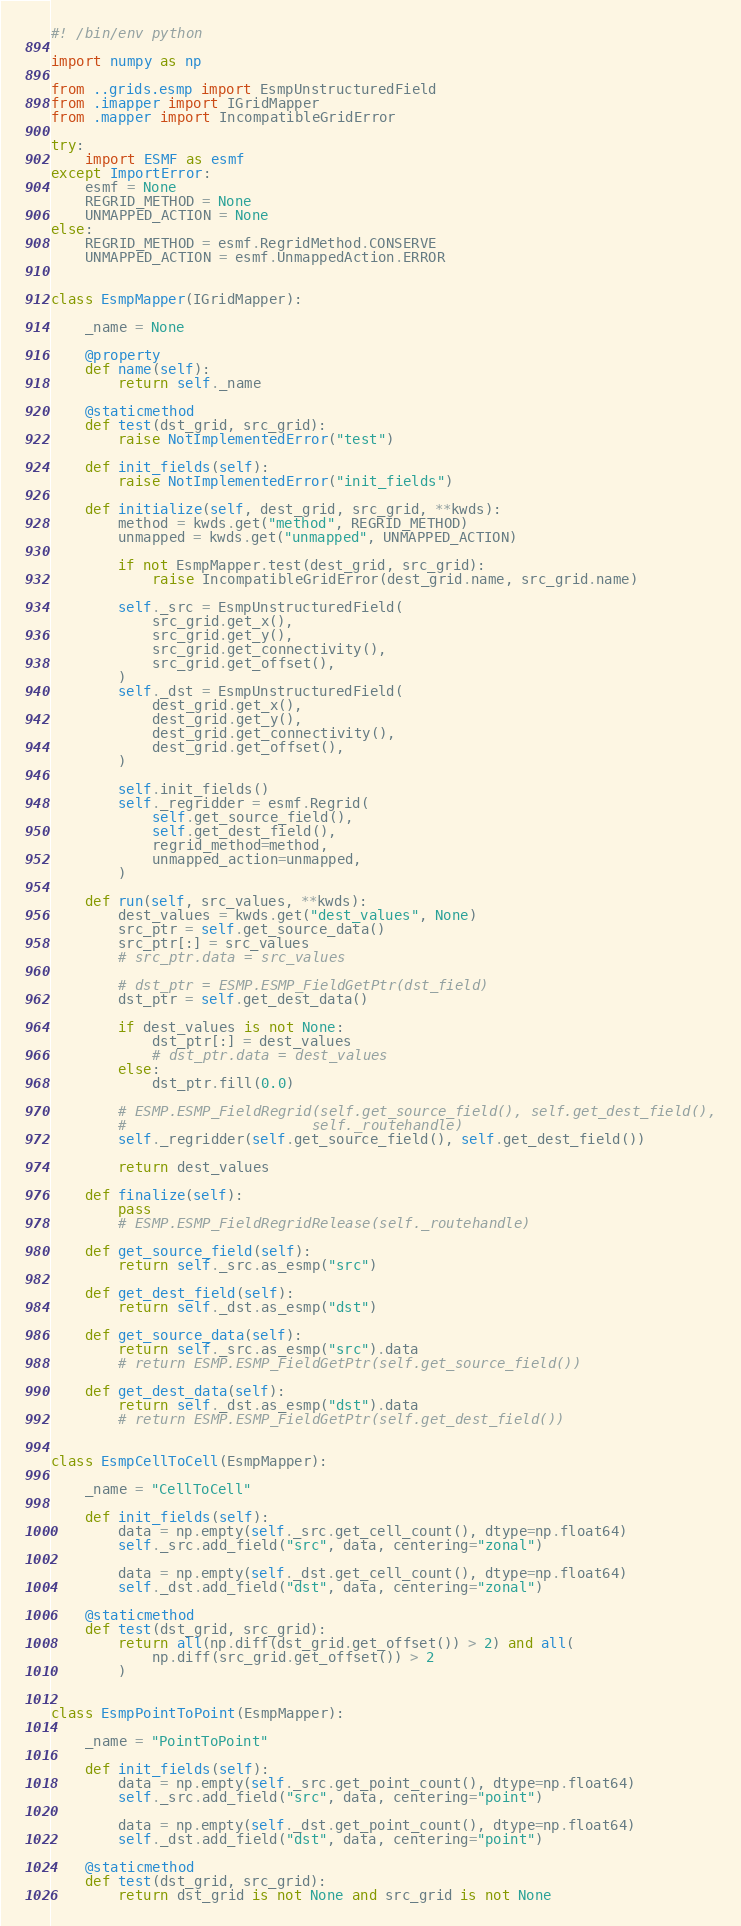Convert code to text. <code><loc_0><loc_0><loc_500><loc_500><_Python_>#! /bin/env python

import numpy as np

from ..grids.esmp import EsmpUnstructuredField
from .imapper import IGridMapper
from .mapper import IncompatibleGridError

try:
    import ESMF as esmf
except ImportError:
    esmf = None
    REGRID_METHOD = None
    UNMAPPED_ACTION = None
else:
    REGRID_METHOD = esmf.RegridMethod.CONSERVE
    UNMAPPED_ACTION = esmf.UnmappedAction.ERROR


class EsmpMapper(IGridMapper):

    _name = None

    @property
    def name(self):
        return self._name

    @staticmethod
    def test(dst_grid, src_grid):
        raise NotImplementedError("test")

    def init_fields(self):
        raise NotImplementedError("init_fields")

    def initialize(self, dest_grid, src_grid, **kwds):
        method = kwds.get("method", REGRID_METHOD)
        unmapped = kwds.get("unmapped", UNMAPPED_ACTION)

        if not EsmpMapper.test(dest_grid, src_grid):
            raise IncompatibleGridError(dest_grid.name, src_grid.name)

        self._src = EsmpUnstructuredField(
            src_grid.get_x(),
            src_grid.get_y(),
            src_grid.get_connectivity(),
            src_grid.get_offset(),
        )
        self._dst = EsmpUnstructuredField(
            dest_grid.get_x(),
            dest_grid.get_y(),
            dest_grid.get_connectivity(),
            dest_grid.get_offset(),
        )

        self.init_fields()
        self._regridder = esmf.Regrid(
            self.get_source_field(),
            self.get_dest_field(),
            regrid_method=method,
            unmapped_action=unmapped,
        )

    def run(self, src_values, **kwds):
        dest_values = kwds.get("dest_values", None)
        src_ptr = self.get_source_data()
        src_ptr[:] = src_values
        # src_ptr.data = src_values

        # dst_ptr = ESMP.ESMP_FieldGetPtr(dst_field)
        dst_ptr = self.get_dest_data()

        if dest_values is not None:
            dst_ptr[:] = dest_values
            # dst_ptr.data = dest_values
        else:
            dst_ptr.fill(0.0)

        # ESMP.ESMP_FieldRegrid(self.get_source_field(), self.get_dest_field(),
        #                      self._routehandle)
        self._regridder(self.get_source_field(), self.get_dest_field())

        return dest_values

    def finalize(self):
        pass
        # ESMP.ESMP_FieldRegridRelease(self._routehandle)

    def get_source_field(self):
        return self._src.as_esmp("src")

    def get_dest_field(self):
        return self._dst.as_esmp("dst")

    def get_source_data(self):
        return self._src.as_esmp("src").data
        # return ESMP.ESMP_FieldGetPtr(self.get_source_field())

    def get_dest_data(self):
        return self._dst.as_esmp("dst").data
        # return ESMP.ESMP_FieldGetPtr(self.get_dest_field())


class EsmpCellToCell(EsmpMapper):

    _name = "CellToCell"

    def init_fields(self):
        data = np.empty(self._src.get_cell_count(), dtype=np.float64)
        self._src.add_field("src", data, centering="zonal")

        data = np.empty(self._dst.get_cell_count(), dtype=np.float64)
        self._dst.add_field("dst", data, centering="zonal")

    @staticmethod
    def test(dst_grid, src_grid):
        return all(np.diff(dst_grid.get_offset()) > 2) and all(
            np.diff(src_grid.get_offset()) > 2
        )


class EsmpPointToPoint(EsmpMapper):

    _name = "PointToPoint"

    def init_fields(self):
        data = np.empty(self._src.get_point_count(), dtype=np.float64)
        self._src.add_field("src", data, centering="point")

        data = np.empty(self._dst.get_point_count(), dtype=np.float64)
        self._dst.add_field("dst", data, centering="point")

    @staticmethod
    def test(dst_grid, src_grid):
        return dst_grid is not None and src_grid is not None
</code> 